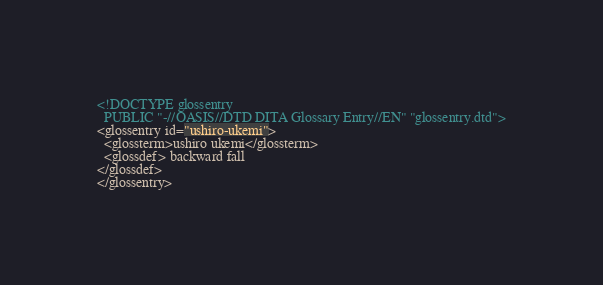Convert code to text. <code><loc_0><loc_0><loc_500><loc_500><_XML_><!DOCTYPE glossentry
  PUBLIC "-//OASIS//DTD DITA Glossary Entry//EN" "glossentry.dtd">
<glossentry id="ushiro-ukemi">
  <glossterm>ushiro ukemi</glossterm>
  <glossdef> backward fall
</glossdef>
</glossentry></code> 